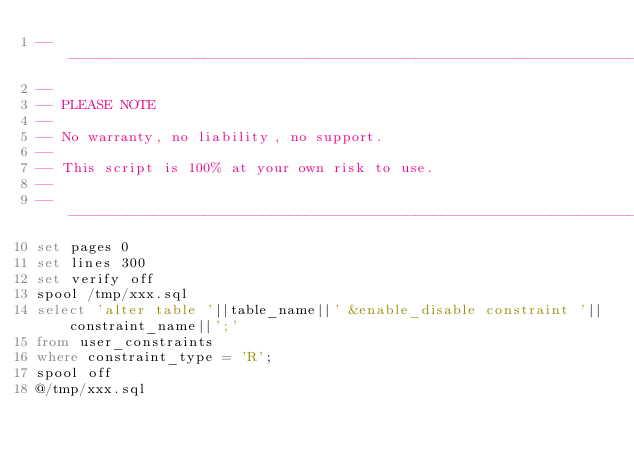Convert code to text. <code><loc_0><loc_0><loc_500><loc_500><_SQL_>-------------------------------------------------------------------------------
--
-- PLEASE NOTE
-- 
-- No warranty, no liability, no support.
--
-- This script is 100% at your own risk to use.
--
-------------------------------------------------------------------------------
set pages 0
set lines 300
set verify off
spool /tmp/xxx.sql
select 'alter table '||table_name||' &enable_disable constraint '||constraint_name||';'
from user_constraints
where constraint_type = 'R';
spool off
@/tmp/xxx.sql
</code> 